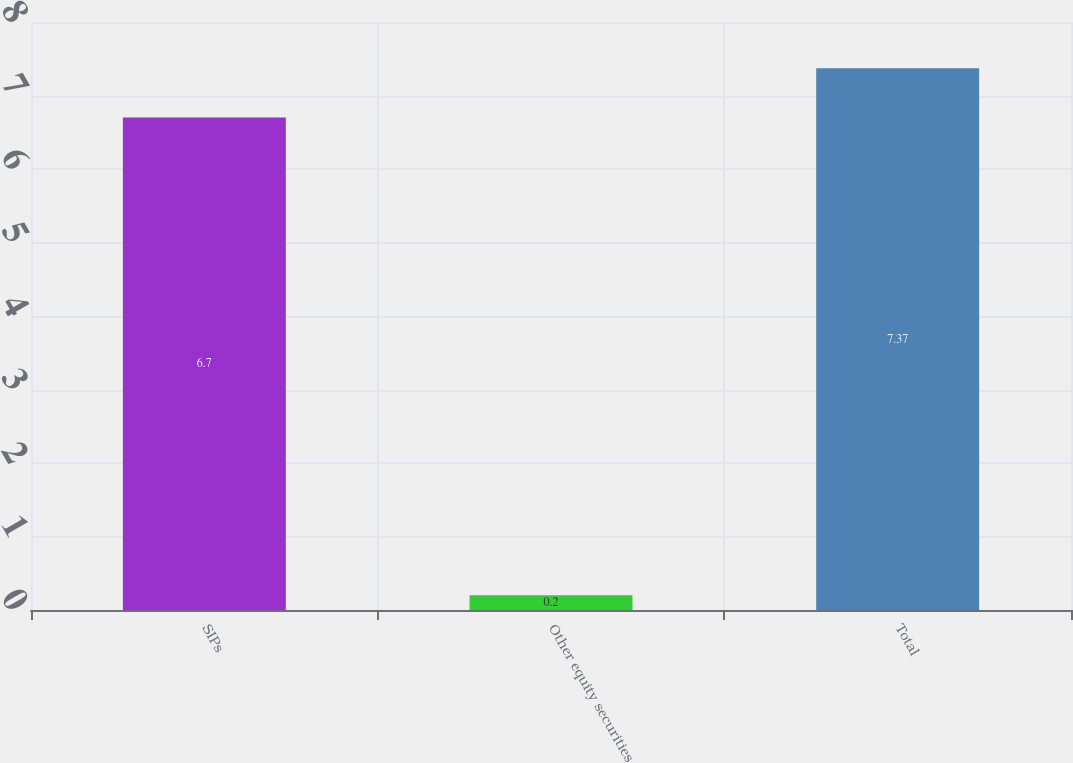<chart> <loc_0><loc_0><loc_500><loc_500><bar_chart><fcel>SIPs<fcel>Other equity securities<fcel>Total<nl><fcel>6.7<fcel>0.2<fcel>7.37<nl></chart> 